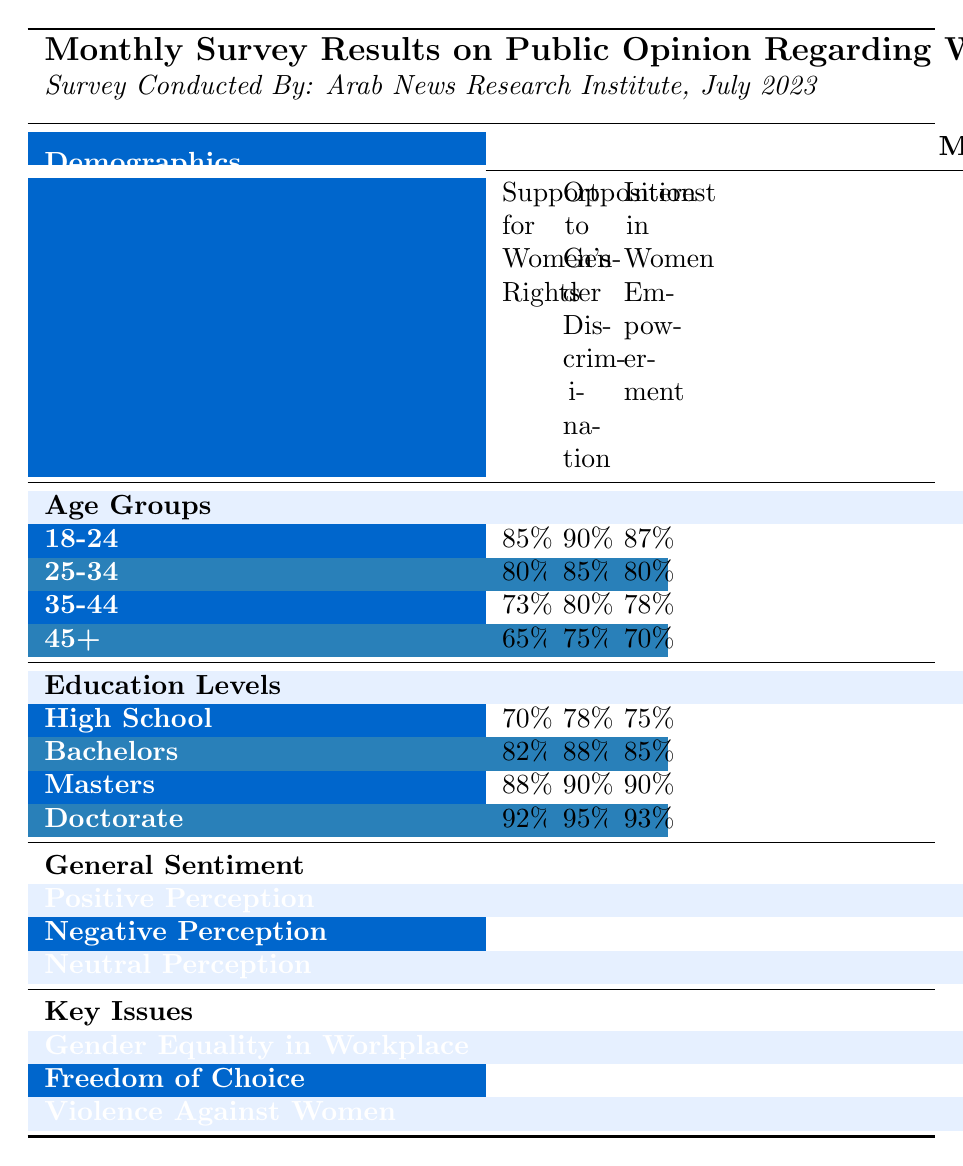What percentage of people aged 18-24 support women's rights? The table shows that 85% of the 18-24 age group support women's rights, which is directly stated in the "Support for Women's Rights" column under the "Age Groups" section.
Answer: 85% What is the opposition to gender discrimination among people with a Doctorate degree? According to the table, the "Opposition to Gender Discrimination" for the Doctorate education level is 95%, which can be found in the "Education Levels" section.
Answer: 95% Which age group shows the least support for women's rights? The age group 45+ has the lowest percentage of support for women's rights at 65%, which is the smallest value in the "Support for Women's Rights" column under the "Age Groups" section.
Answer: 45+ What is the difference in support for women's rights between the 18-24 age group and the 35-44 age group? The support for women's rights in the 18-24 age group is 85%, while in the 35-44 age group it is 73%. The difference is calculated as 85% - 73% = 12%.
Answer: 12% What percentage of respondents have a positive perception of women's rights? The general sentiment section of the table indicates that 78% of respondents have a positive perception of women's rights.
Answer: 78% Is the opposition to gender discrimination higher among Bachelors or Masters degree holders? The table indicates that opposition to gender discrimination is 88% for Bachelors and 90% for Masters degree holders. Since 90% is greater than 88%, Masters degree holders have higher opposition.
Answer: Yes What is the average interest in women empowerment across all age groups? To find the average interest, we can sum the interests: (87% + 80% + 78% + 70%) = 315%. There are four age groups, so the average is 315% / 4 = 78.75%.
Answer: 78.75% Among the key issues listed, which issue has the highest percentage? In the "Key Issues" section, the highest percentage is for "Gender Equality in Workplace," which is at 42%. This can be easily identified as the largest value among the three issues listed.
Answer: Gender Equality in Workplace What is the percentage of those aged 25-34 interested in women's empowerment? The table specifies that the interest in women's empowerment for the 25-34 age group is 80%, found in the "Interest in Women Empowerment" column under the "Age Groups" section.
Answer: 80% Are the positive perceptions of women's rights among those with a Master's degree higher or lower than the overall positive perception? The positive perception for those with a Master's degree is 90%, while the overall positive perception is 78%. Since 90% is greater than 78%, the Master's degree holders have higher positive perceptions.
Answer: Higher 